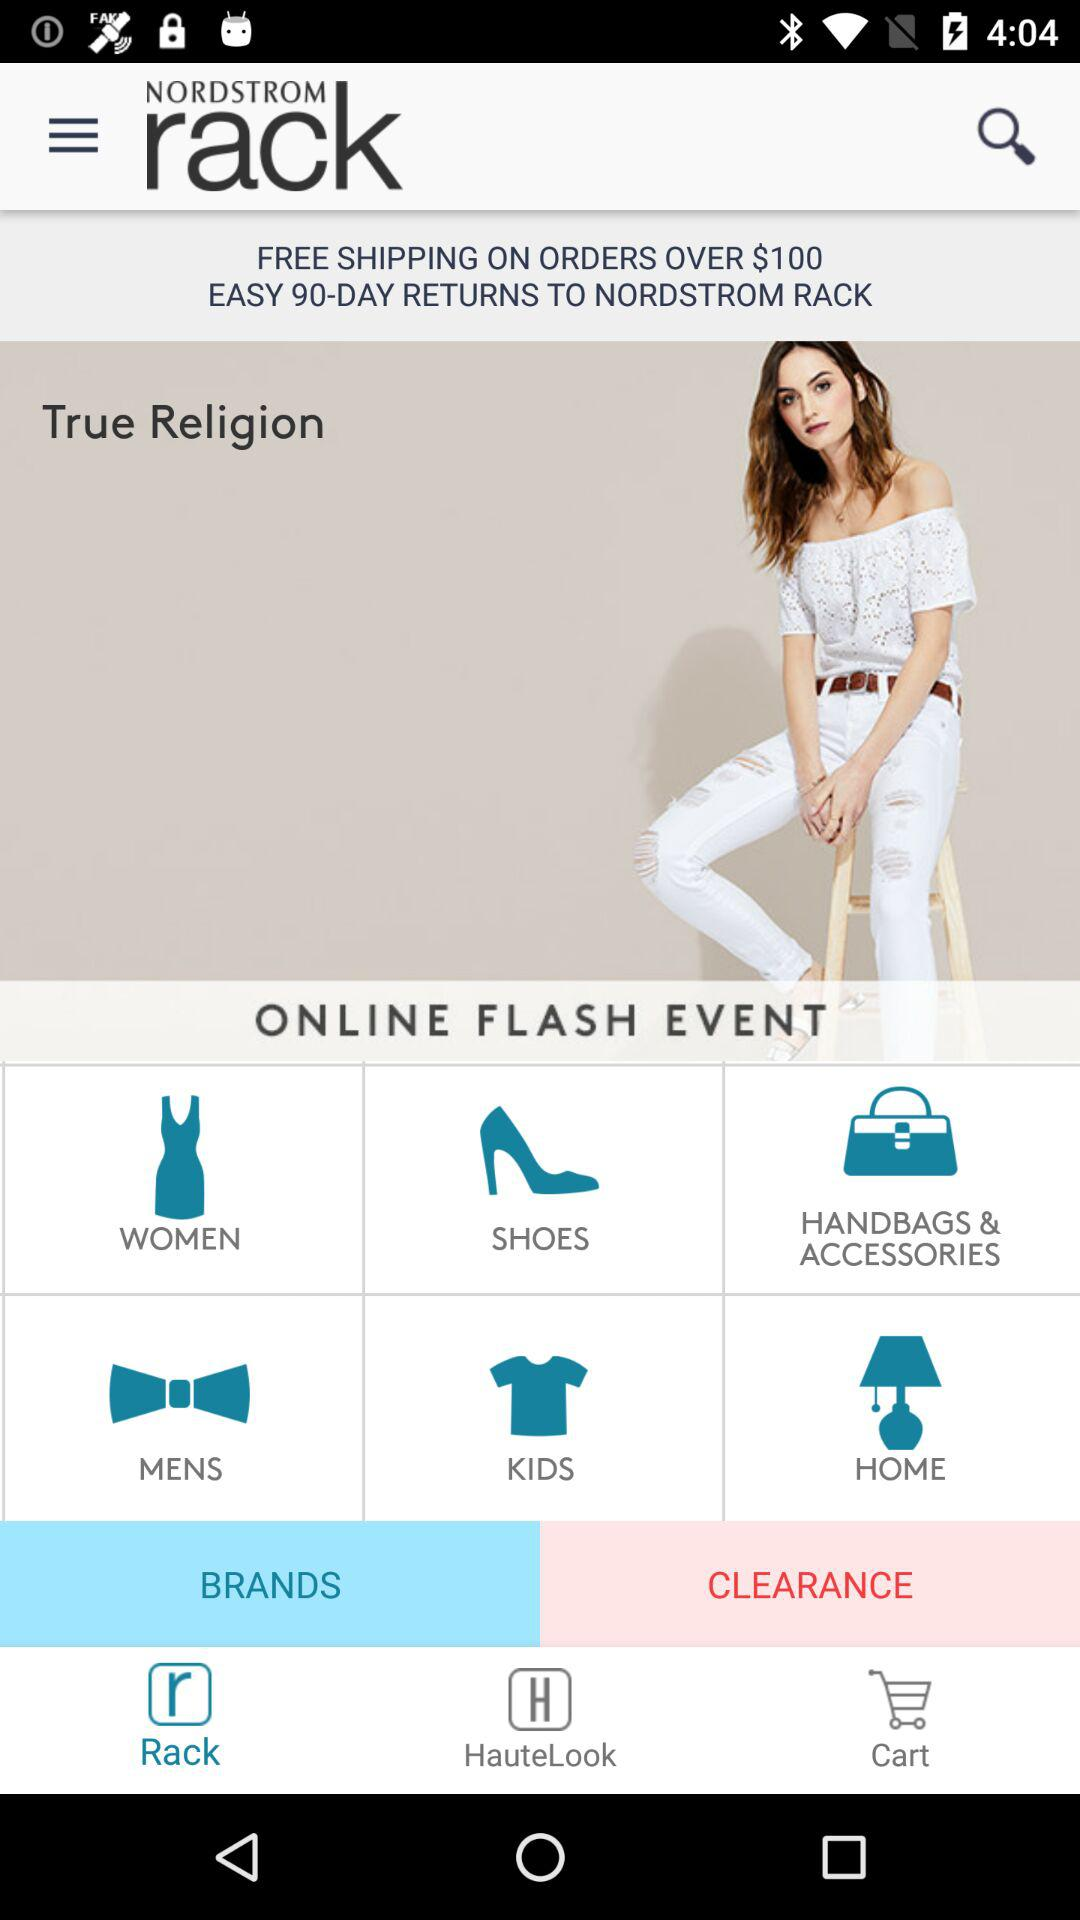What is the application name? The application name is "NORDSTROM rack". 